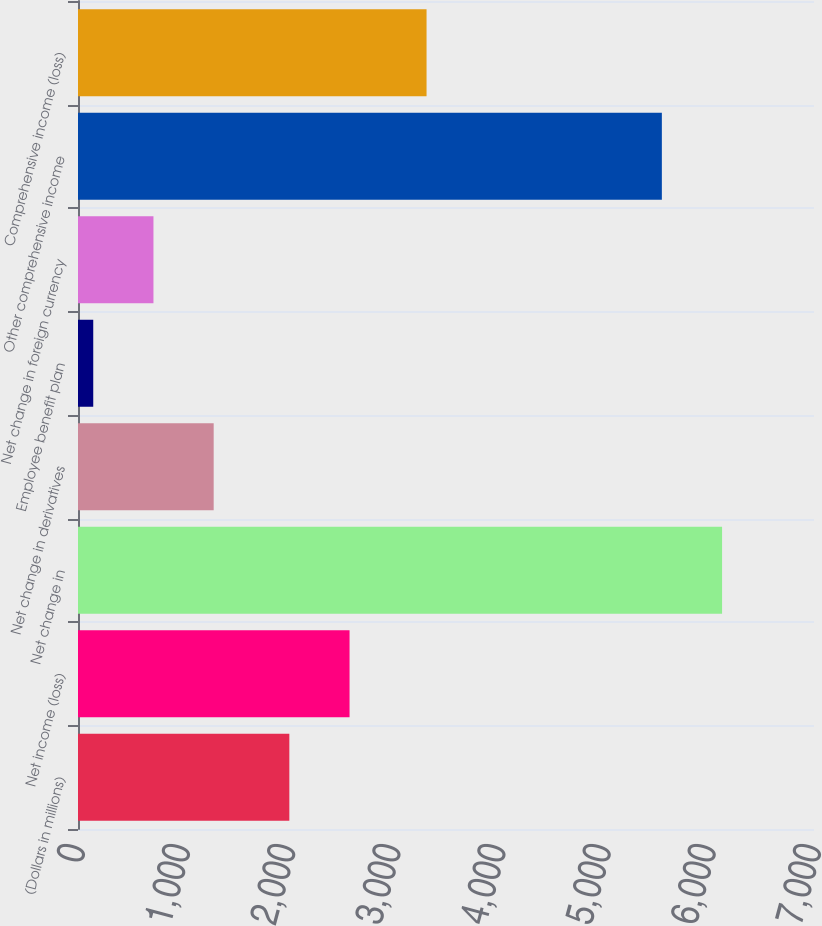<chart> <loc_0><loc_0><loc_500><loc_500><bar_chart><fcel>(Dollars in millions)<fcel>Net income (loss)<fcel>Net change in<fcel>Net change in derivatives<fcel>Employee benefit plan<fcel>Net change in foreign currency<fcel>Other comprehensive income<fcel>Comprehensive income (loss)<nl><fcel>2010<fcel>2582.7<fcel>6125.7<fcel>1290.4<fcel>145<fcel>717.7<fcel>5553<fcel>3315<nl></chart> 